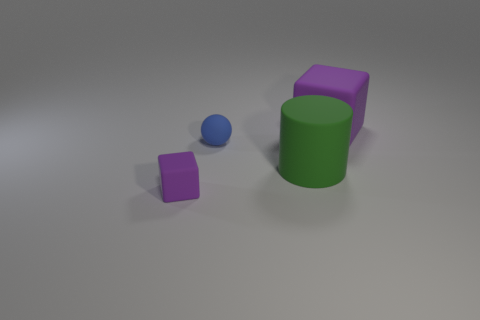What material is the thing that is both on the left side of the large cylinder and in front of the small ball?
Give a very brief answer. Rubber. How many other big things are the same shape as the big purple thing?
Make the answer very short. 0. What is the material of the cube left of the big purple block?
Provide a short and direct response. Rubber. Is the number of matte cylinders left of the tiny purple matte thing less than the number of green metal balls?
Offer a terse response. No. Do the small purple object and the blue rubber object have the same shape?
Your response must be concise. No. Are there any other things that are the same shape as the green rubber object?
Give a very brief answer. No. Are any small gray metallic cylinders visible?
Provide a succinct answer. No. Does the small purple object have the same shape as the purple object that is behind the blue matte object?
Provide a short and direct response. Yes. What is the material of the cube that is behind the rubber cube in front of the large purple rubber object?
Give a very brief answer. Rubber. What is the color of the tiny cube?
Ensure brevity in your answer.  Purple. 